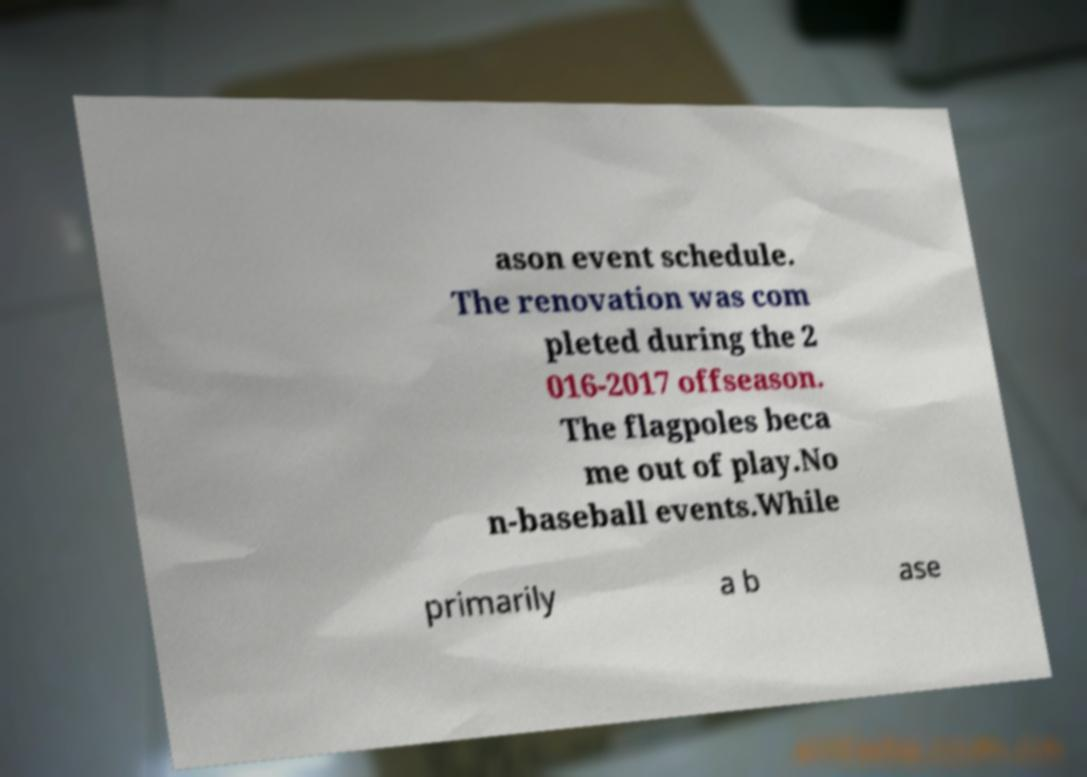Can you accurately transcribe the text from the provided image for me? ason event schedule. The renovation was com pleted during the 2 016-2017 offseason. The flagpoles beca me out of play.No n-baseball events.While primarily a b ase 